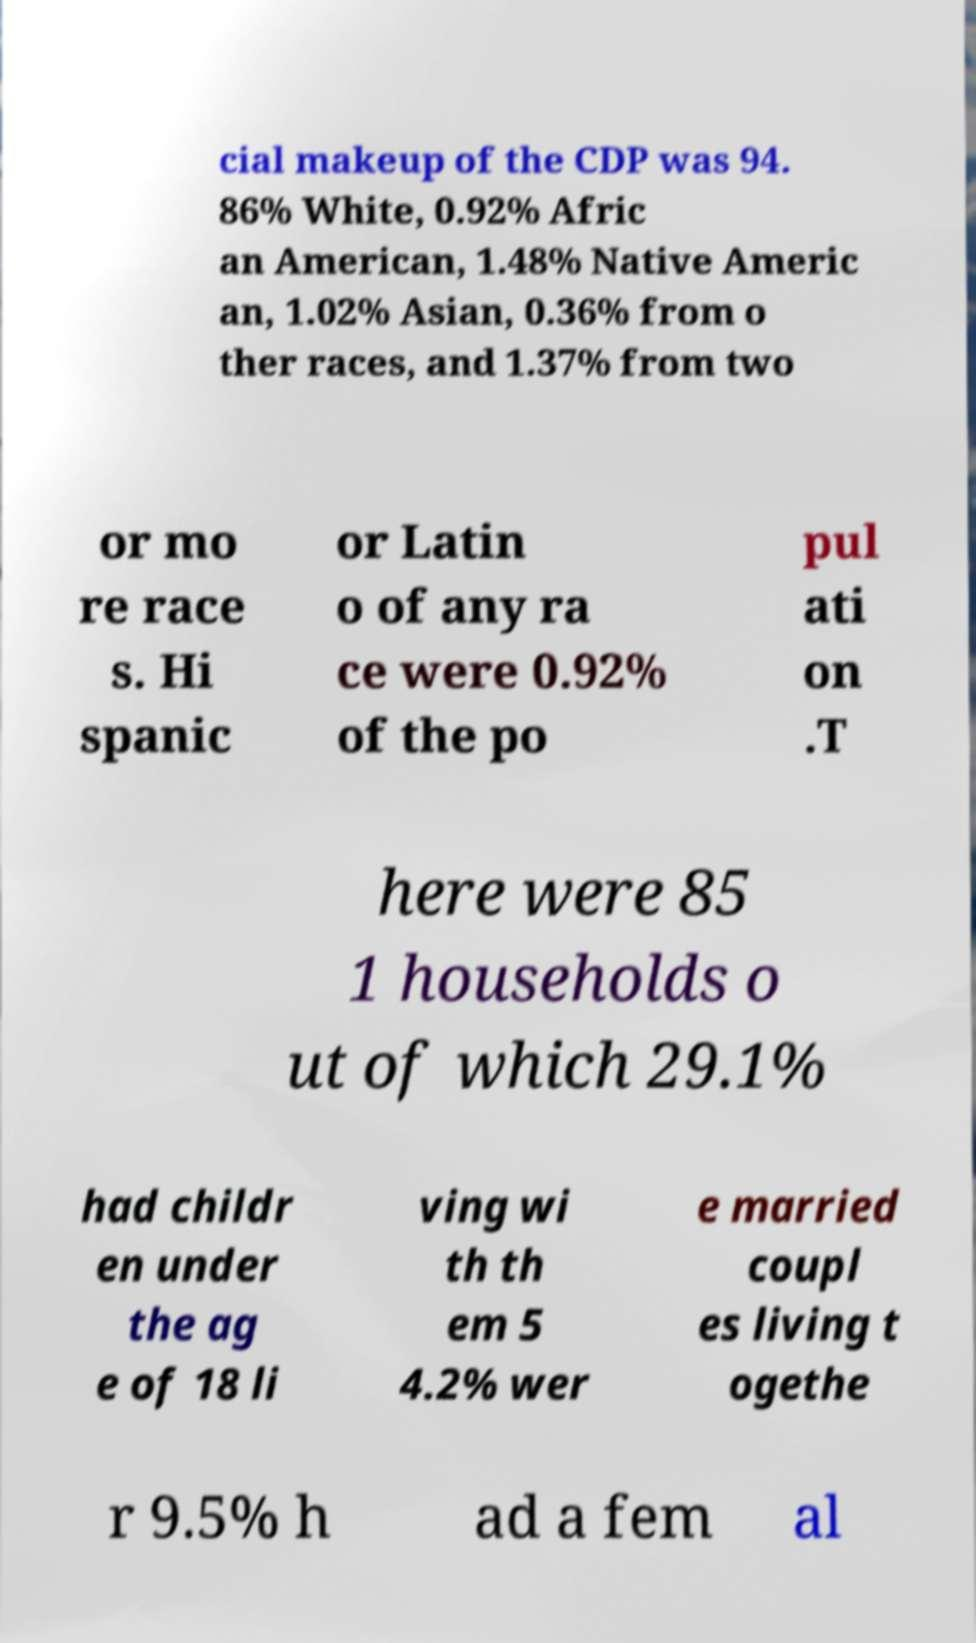Please identify and transcribe the text found in this image. cial makeup of the CDP was 94. 86% White, 0.92% Afric an American, 1.48% Native Americ an, 1.02% Asian, 0.36% from o ther races, and 1.37% from two or mo re race s. Hi spanic or Latin o of any ra ce were 0.92% of the po pul ati on .T here were 85 1 households o ut of which 29.1% had childr en under the ag e of 18 li ving wi th th em 5 4.2% wer e married coupl es living t ogethe r 9.5% h ad a fem al 